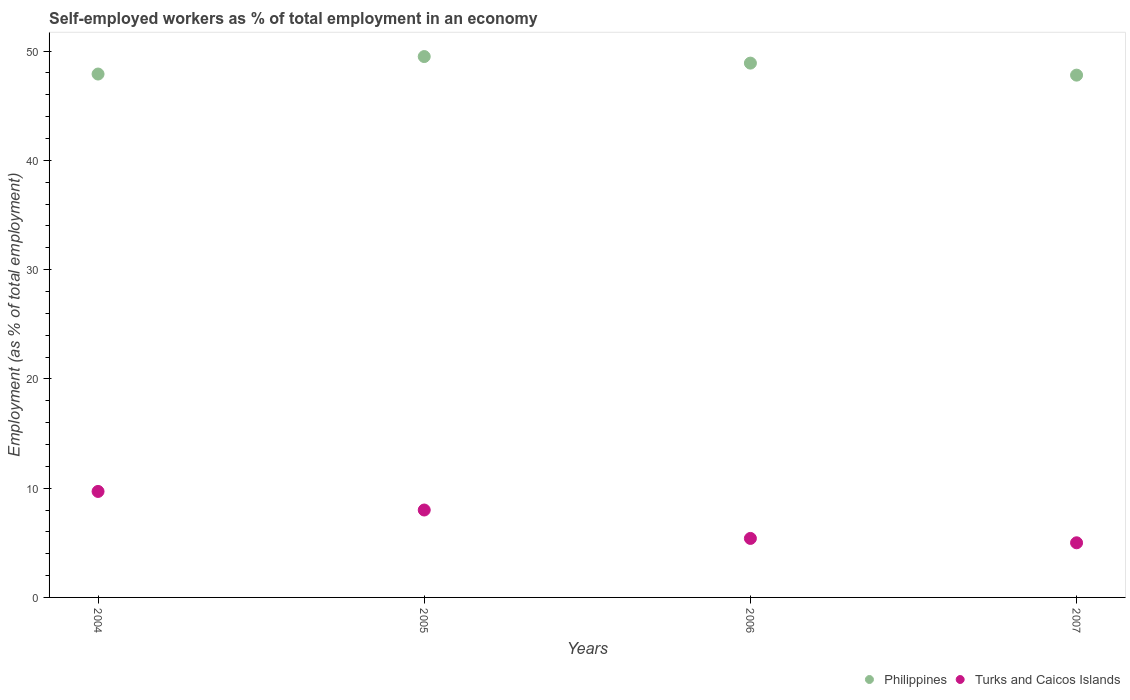How many different coloured dotlines are there?
Offer a very short reply. 2. Across all years, what is the maximum percentage of self-employed workers in Turks and Caicos Islands?
Provide a short and direct response. 9.7. In which year was the percentage of self-employed workers in Philippines maximum?
Offer a very short reply. 2005. What is the total percentage of self-employed workers in Philippines in the graph?
Offer a terse response. 194.1. What is the difference between the percentage of self-employed workers in Turks and Caicos Islands in 2006 and that in 2007?
Make the answer very short. 0.4. What is the difference between the percentage of self-employed workers in Philippines in 2006 and the percentage of self-employed workers in Turks and Caicos Islands in 2004?
Provide a succinct answer. 39.2. What is the average percentage of self-employed workers in Philippines per year?
Keep it short and to the point. 48.53. In the year 2005, what is the difference between the percentage of self-employed workers in Philippines and percentage of self-employed workers in Turks and Caicos Islands?
Your answer should be very brief. 41.5. In how many years, is the percentage of self-employed workers in Turks and Caicos Islands greater than 26 %?
Offer a very short reply. 0. What is the ratio of the percentage of self-employed workers in Philippines in 2004 to that in 2005?
Make the answer very short. 0.97. What is the difference between the highest and the second highest percentage of self-employed workers in Turks and Caicos Islands?
Your answer should be compact. 1.7. What is the difference between the highest and the lowest percentage of self-employed workers in Turks and Caicos Islands?
Your response must be concise. 4.7. In how many years, is the percentage of self-employed workers in Philippines greater than the average percentage of self-employed workers in Philippines taken over all years?
Offer a very short reply. 2. Is the percentage of self-employed workers in Philippines strictly greater than the percentage of self-employed workers in Turks and Caicos Islands over the years?
Make the answer very short. Yes. Is the percentage of self-employed workers in Turks and Caicos Islands strictly less than the percentage of self-employed workers in Philippines over the years?
Your answer should be compact. Yes. Where does the legend appear in the graph?
Provide a short and direct response. Bottom right. How many legend labels are there?
Give a very brief answer. 2. What is the title of the graph?
Ensure brevity in your answer.  Self-employed workers as % of total employment in an economy. What is the label or title of the Y-axis?
Keep it short and to the point. Employment (as % of total employment). What is the Employment (as % of total employment) of Philippines in 2004?
Offer a very short reply. 47.9. What is the Employment (as % of total employment) of Turks and Caicos Islands in 2004?
Your answer should be very brief. 9.7. What is the Employment (as % of total employment) in Philippines in 2005?
Your answer should be very brief. 49.5. What is the Employment (as % of total employment) of Philippines in 2006?
Offer a very short reply. 48.9. What is the Employment (as % of total employment) in Turks and Caicos Islands in 2006?
Ensure brevity in your answer.  5.4. What is the Employment (as % of total employment) in Philippines in 2007?
Ensure brevity in your answer.  47.8. What is the Employment (as % of total employment) in Turks and Caicos Islands in 2007?
Your answer should be compact. 5. Across all years, what is the maximum Employment (as % of total employment) in Philippines?
Your answer should be very brief. 49.5. Across all years, what is the maximum Employment (as % of total employment) in Turks and Caicos Islands?
Give a very brief answer. 9.7. Across all years, what is the minimum Employment (as % of total employment) in Philippines?
Offer a very short reply. 47.8. What is the total Employment (as % of total employment) in Philippines in the graph?
Offer a very short reply. 194.1. What is the total Employment (as % of total employment) of Turks and Caicos Islands in the graph?
Keep it short and to the point. 28.1. What is the difference between the Employment (as % of total employment) of Philippines in 2004 and that in 2005?
Offer a very short reply. -1.6. What is the difference between the Employment (as % of total employment) of Turks and Caicos Islands in 2004 and that in 2006?
Your answer should be very brief. 4.3. What is the difference between the Employment (as % of total employment) of Philippines in 2005 and that in 2006?
Keep it short and to the point. 0.6. What is the difference between the Employment (as % of total employment) of Turks and Caicos Islands in 2005 and that in 2006?
Keep it short and to the point. 2.6. What is the difference between the Employment (as % of total employment) of Philippines in 2006 and that in 2007?
Provide a succinct answer. 1.1. What is the difference between the Employment (as % of total employment) of Philippines in 2004 and the Employment (as % of total employment) of Turks and Caicos Islands in 2005?
Your answer should be very brief. 39.9. What is the difference between the Employment (as % of total employment) in Philippines in 2004 and the Employment (as % of total employment) in Turks and Caicos Islands in 2006?
Your answer should be very brief. 42.5. What is the difference between the Employment (as % of total employment) of Philippines in 2004 and the Employment (as % of total employment) of Turks and Caicos Islands in 2007?
Provide a succinct answer. 42.9. What is the difference between the Employment (as % of total employment) of Philippines in 2005 and the Employment (as % of total employment) of Turks and Caicos Islands in 2006?
Offer a very short reply. 44.1. What is the difference between the Employment (as % of total employment) in Philippines in 2005 and the Employment (as % of total employment) in Turks and Caicos Islands in 2007?
Ensure brevity in your answer.  44.5. What is the difference between the Employment (as % of total employment) in Philippines in 2006 and the Employment (as % of total employment) in Turks and Caicos Islands in 2007?
Offer a terse response. 43.9. What is the average Employment (as % of total employment) in Philippines per year?
Keep it short and to the point. 48.52. What is the average Employment (as % of total employment) of Turks and Caicos Islands per year?
Your answer should be compact. 7.03. In the year 2004, what is the difference between the Employment (as % of total employment) in Philippines and Employment (as % of total employment) in Turks and Caicos Islands?
Make the answer very short. 38.2. In the year 2005, what is the difference between the Employment (as % of total employment) in Philippines and Employment (as % of total employment) in Turks and Caicos Islands?
Provide a short and direct response. 41.5. In the year 2006, what is the difference between the Employment (as % of total employment) in Philippines and Employment (as % of total employment) in Turks and Caicos Islands?
Keep it short and to the point. 43.5. In the year 2007, what is the difference between the Employment (as % of total employment) of Philippines and Employment (as % of total employment) of Turks and Caicos Islands?
Your response must be concise. 42.8. What is the ratio of the Employment (as % of total employment) in Turks and Caicos Islands in 2004 to that in 2005?
Your response must be concise. 1.21. What is the ratio of the Employment (as % of total employment) in Philippines in 2004 to that in 2006?
Keep it short and to the point. 0.98. What is the ratio of the Employment (as % of total employment) in Turks and Caicos Islands in 2004 to that in 2006?
Give a very brief answer. 1.8. What is the ratio of the Employment (as % of total employment) of Turks and Caicos Islands in 2004 to that in 2007?
Provide a short and direct response. 1.94. What is the ratio of the Employment (as % of total employment) of Philippines in 2005 to that in 2006?
Your answer should be compact. 1.01. What is the ratio of the Employment (as % of total employment) in Turks and Caicos Islands in 2005 to that in 2006?
Offer a terse response. 1.48. What is the ratio of the Employment (as % of total employment) of Philippines in 2005 to that in 2007?
Your answer should be very brief. 1.04. What is the ratio of the Employment (as % of total employment) in Turks and Caicos Islands in 2006 to that in 2007?
Offer a very short reply. 1.08. What is the difference between the highest and the second highest Employment (as % of total employment) in Philippines?
Your response must be concise. 0.6. What is the difference between the highest and the second highest Employment (as % of total employment) in Turks and Caicos Islands?
Give a very brief answer. 1.7. 